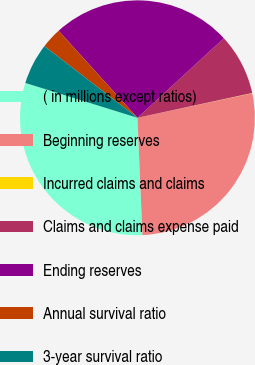Convert chart to OTSL. <chart><loc_0><loc_0><loc_500><loc_500><pie_chart><fcel>( in millions except ratios)<fcel>Beginning reserves<fcel>Incurred claims and claims<fcel>Claims and claims expense paid<fcel>Ending reserves<fcel>Annual survival ratio<fcel>3-year survival ratio<nl><fcel>30.47%<fcel>27.67%<fcel>0.04%<fcel>8.45%<fcel>24.87%<fcel>2.84%<fcel>5.65%<nl></chart> 